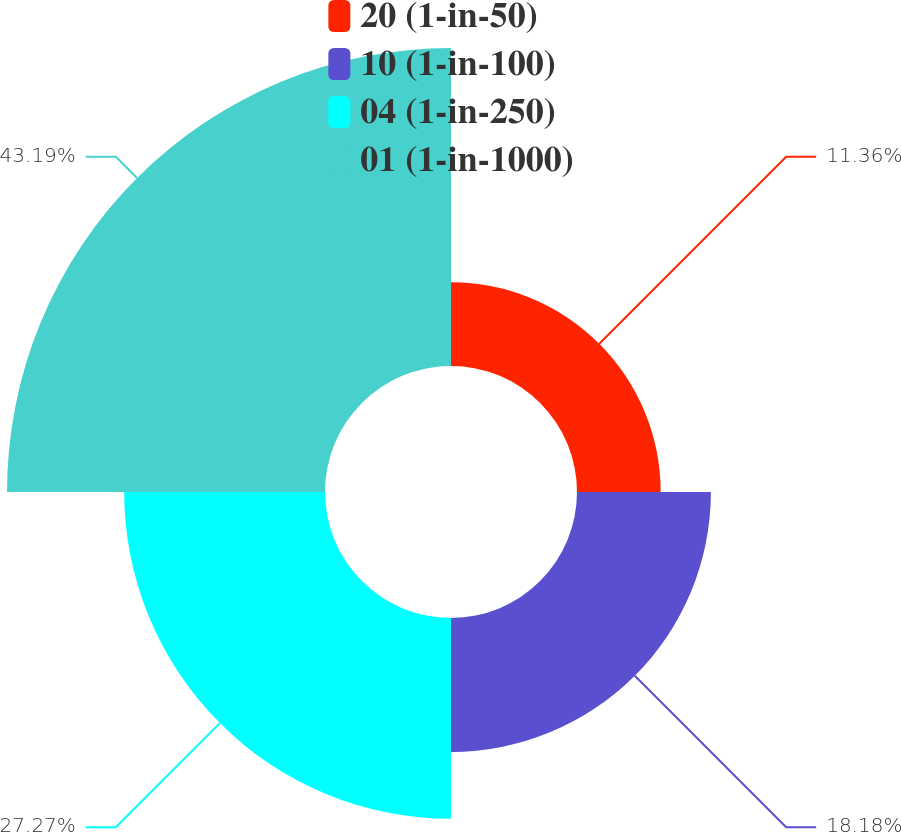Convert chart. <chart><loc_0><loc_0><loc_500><loc_500><pie_chart><fcel>20 (1-in-50)<fcel>10 (1-in-100)<fcel>04 (1-in-250)<fcel>01 (1-in-1000)<nl><fcel>11.36%<fcel>18.18%<fcel>27.27%<fcel>43.18%<nl></chart> 